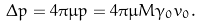<formula> <loc_0><loc_0><loc_500><loc_500>\Delta p = 4 \pi \mu p = 4 \pi \mu M \gamma _ { 0 } v _ { 0 } .</formula> 